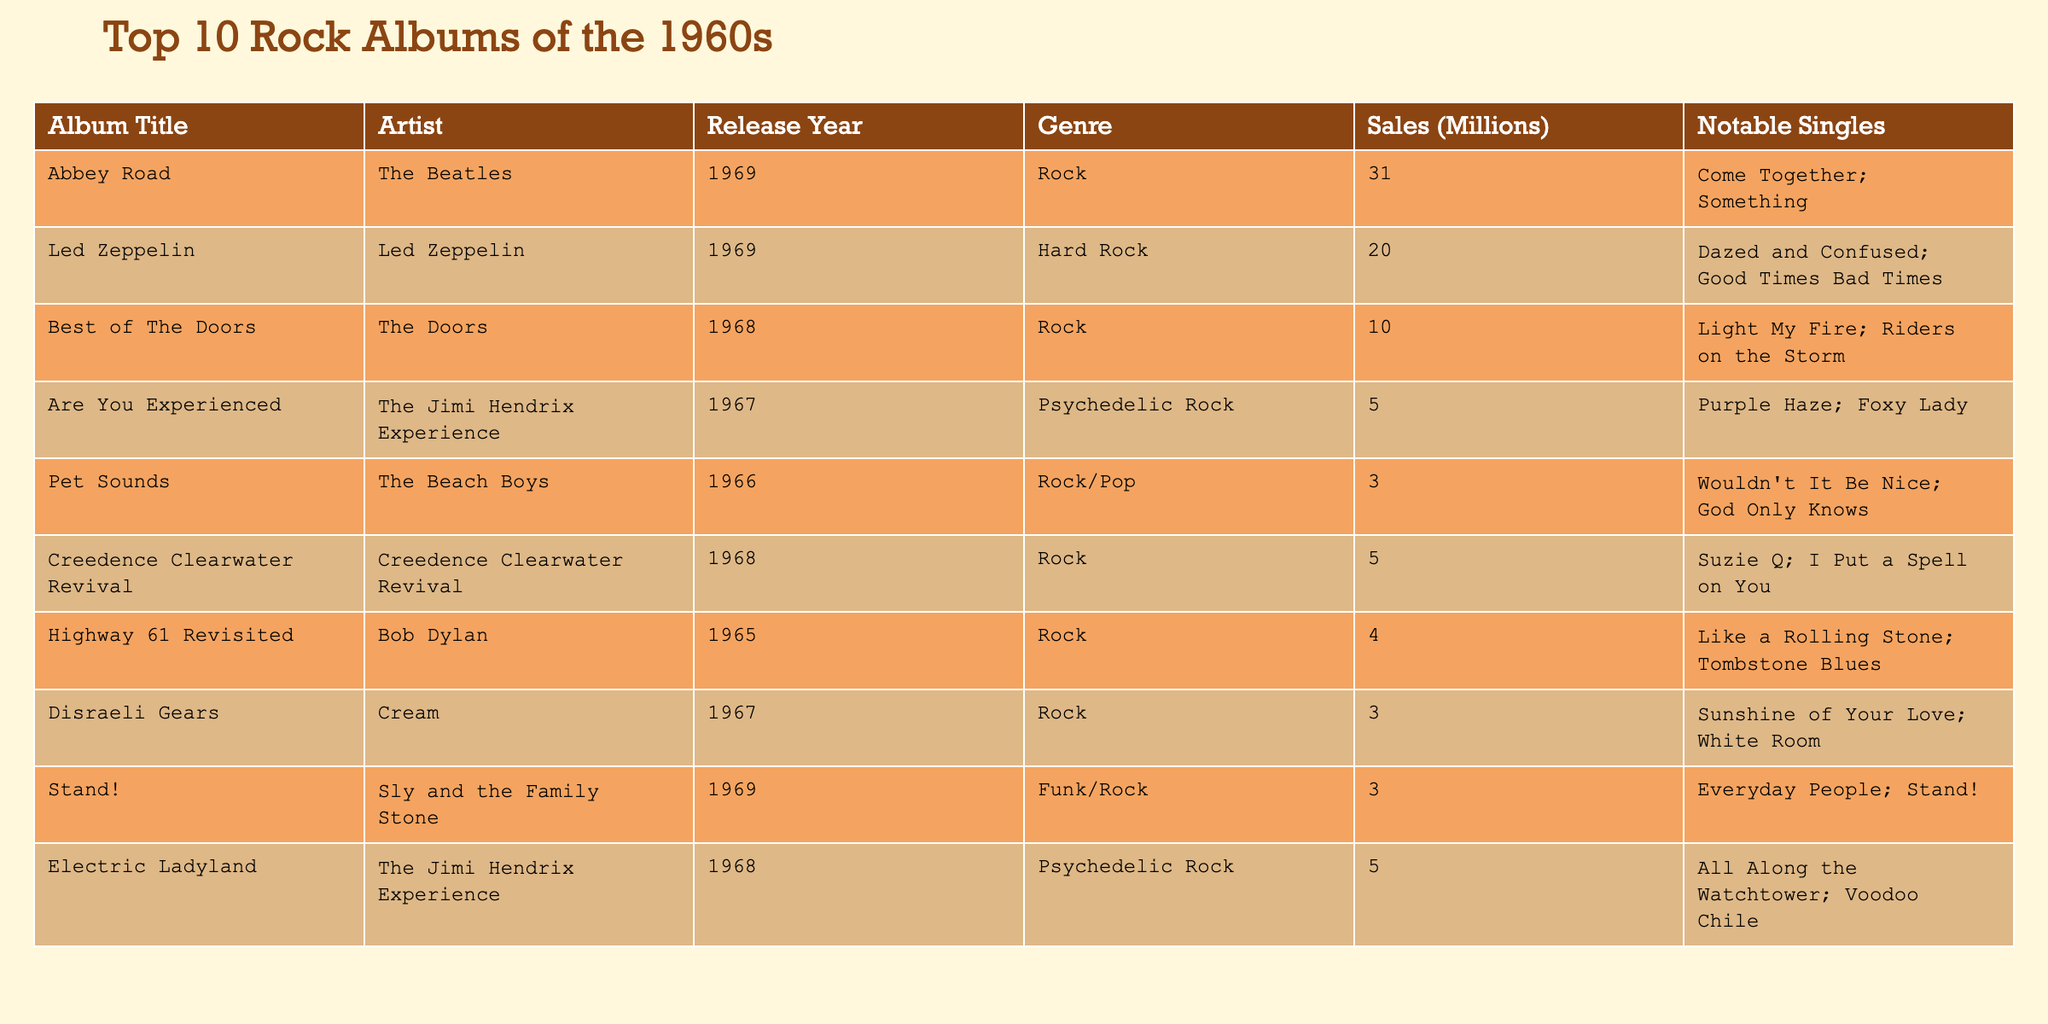What is the highest-selling rock album from the 1960s according to the table? The table lists "Abbey Road" by The Beatles with sales of 31 million units as the highest-selling rock album.
Answer: Abbey Road How many albums by The Jimi Hendrix Experience are in the top 10? There are two albums by The Jimi Hendrix Experience listed: "Are You Experienced" and "Electric Ladyland."
Answer: 2 Which artist has the album with the lowest sales in the table? "Pet Sounds" by The Beach Boys has the lowest sales at 3 million units. This is lower than the sales of all other listed albums.
Answer: The Beach Boys What is the combined sales of Creedence Clearwater Revival and The Doors? Creedence Clearwater Revival has sales of 5 million, and The Doors has sales of 10 million. Therefore, the combined sales are 5 + 10 = 15 million.
Answer: 15 million Is "Highway 61 Revisited" by Bob Dylan part of the top 10 rock albums according to the table? Yes, "Highway 61 Revisited" is included in the table with sales of 4 million units, confirming its part in the top 10 albums.
Answer: Yes What percentage of total sales do the top 3 albums account for? The top 3 albums are "Abbey Road" (31M), "Led Zeppelin" (20M), and "Best of The Doors" (10M), totaling 31 + 20 + 10 = 61 million. The total sales of all albums in the table are 31 + 20 + 10 + 5 + 3 + 5 + 4 + 3 + 3 + 5 = 83 million. Therefore, the percentage is (61/83) * 100 ≈ 73.49%.
Answer: Approximately 73.49% Which album has the most notable singles listed, and how many are there? "Electric Ladyland" has two notable singles: "All Along the Watchtower" and "Voodoo Chile." It is one of the few albums with this number, but others also may have two singles listed. The analysis of singles shows this album is tied with other entries.
Answer: Electric Ladyland, 2 singles What genre does the album "Stand!" belong to, and which year was it released? "Stand!" is categorized under the genre Funk/Rock and was released in 1969, as indicated in the table.
Answer: Funk/Rock, 1969 